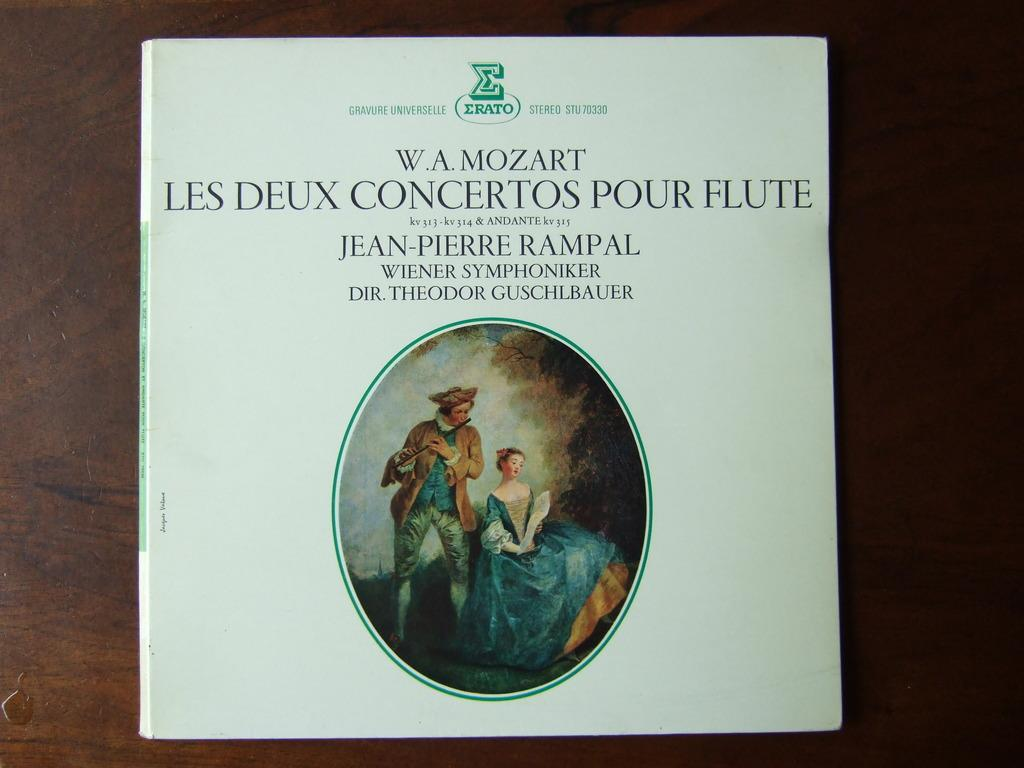<image>
Write a terse but informative summary of the picture. An album of Mozart music features Jean-Pierre Rampal. 